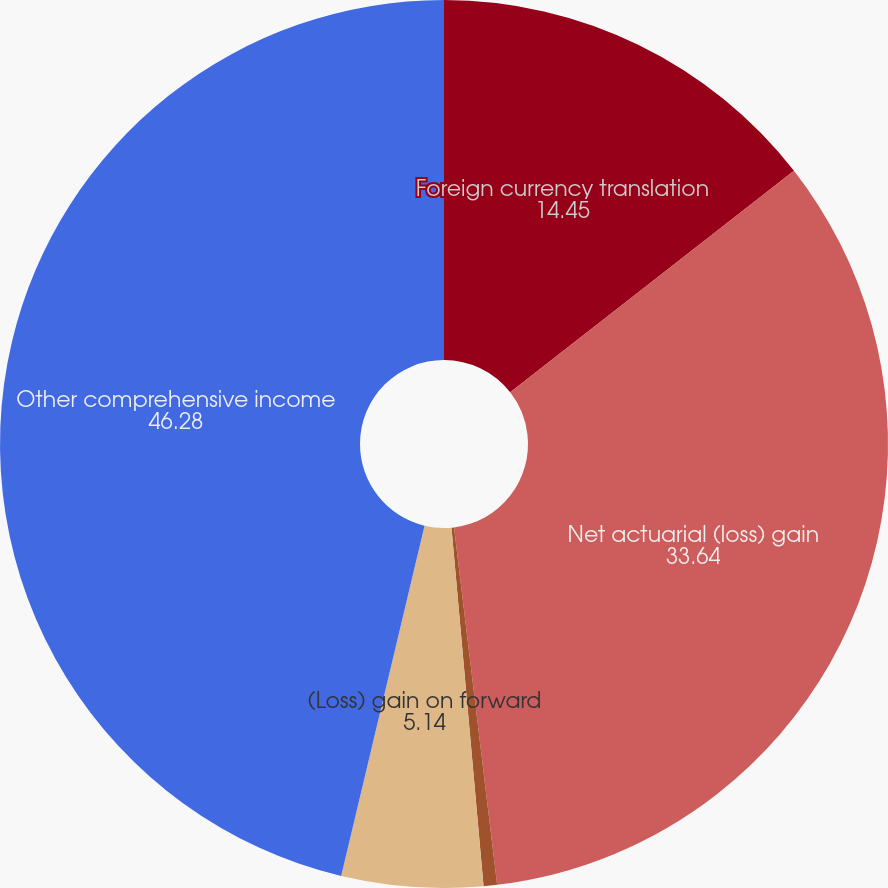Convert chart. <chart><loc_0><loc_0><loc_500><loc_500><pie_chart><fcel>Foreign currency translation<fcel>Net actuarial (loss) gain<fcel>Amortization of unrecognized<fcel>(Loss) gain on forward<fcel>Other comprehensive income<nl><fcel>14.45%<fcel>33.64%<fcel>0.49%<fcel>5.14%<fcel>46.28%<nl></chart> 